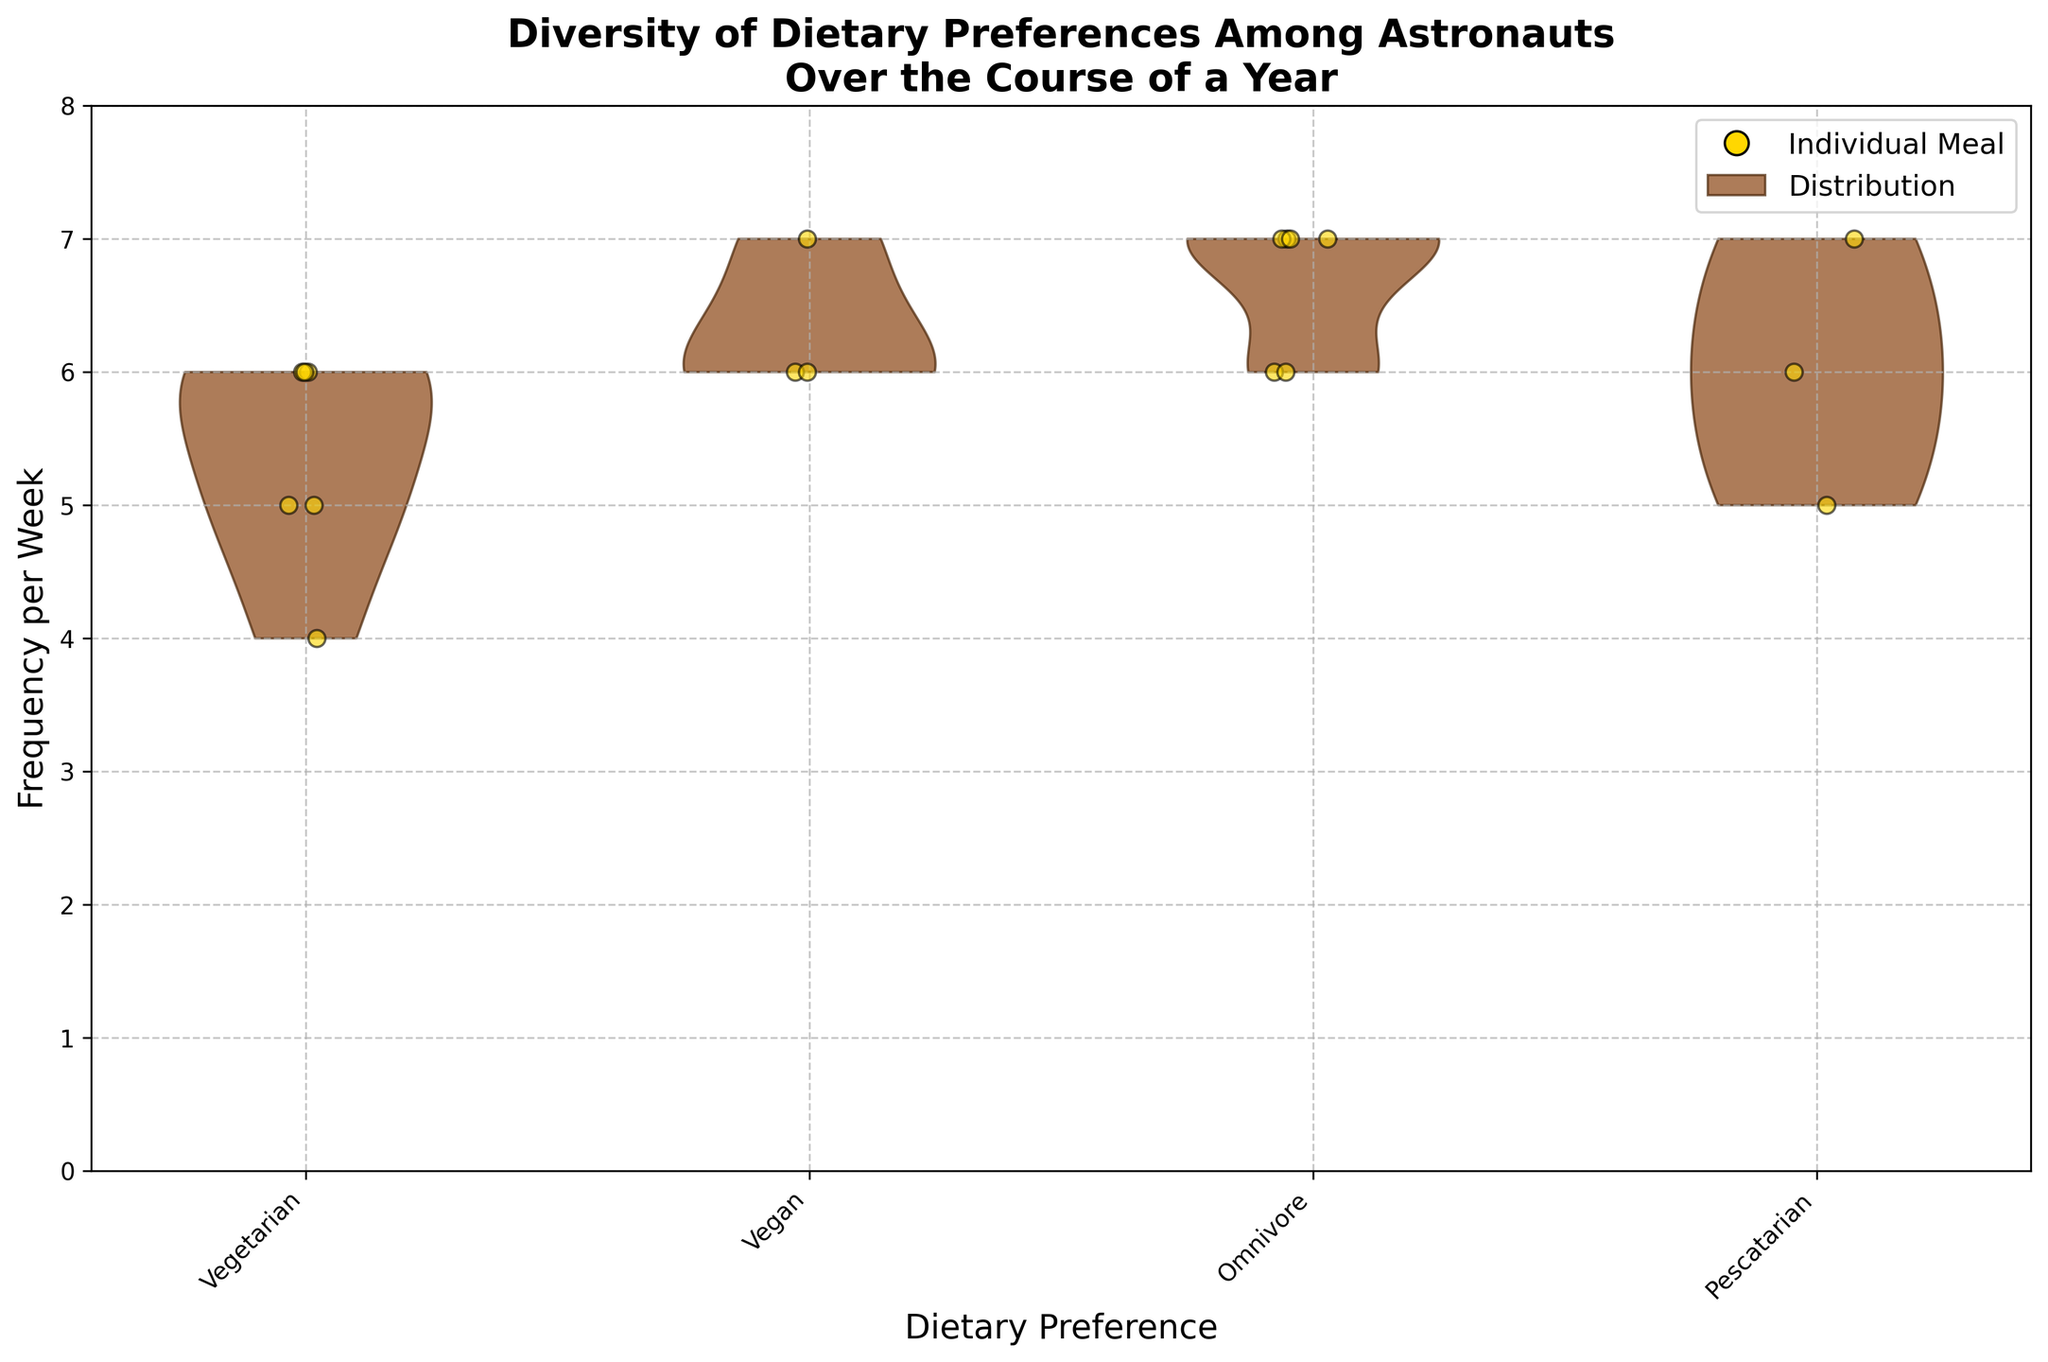What is the main title of the plot? The main title is located at the top of the plot and is the biggest text in bold font.
Answer: Diversity of Dietary Preferences Among Astronauts Over the Course of a Year How many dietary preferences are represented in the plot? By looking at the x-axis labels, we can count the number of distinct dietary preferences. There are four labeled positions on the x-axis.
Answer: 4 What does the yellow color represent in the plot? The legend indicates that the yellow points, marked as 'Individual Meal', denote the frequency per week for each meal individually.
Answer: Individual Meal Which dietary preference shows the most variation in meal frequency per week? The dietary preference with the broadest and most spread-out violin plot body reflects the most variation in meal frequency per week.
Answer: Vegetarian Is there any dietary preference where all meal frequencies are the same? By inspecting the jittered points within each violin plot, if the points are all at the same frequency level, it means there is no variation.
Answer: Omnivore Which dietary preference has the highest median meal frequency? The median is represented by the central tendency of the distribution in the violin plot. Identifying the highest central distribution gives the answer.
Answer: Vegan How does the frequency per week of breakfast for Sarah Walker compare with that of John Smith? Relative placement of the jittered points for Sarah Walker and John Smith at the 'Breakfast' frequency level on the y-axis helps give the comparison.
Answer: Lower What is the range of meal frequencies per week for pescatarians? Observing the top and bottom extent of the violin plot for pescatarians gives the highest and lowest meal frequencies.
Answer: 5 to 7 Which dietary preference has the most consistently high meal frequencies across all meal types? By examining the density and position of the points and the shape of the distribution, we can determine the dietary preference with high and consistent meal frequencies.
Answer: Omnivore What is the most common frequency per week for vegetarian meals? By looking at the largest density areas in the violin plot for vegetarians, we can infer the most common frequency.
Answer: 6 